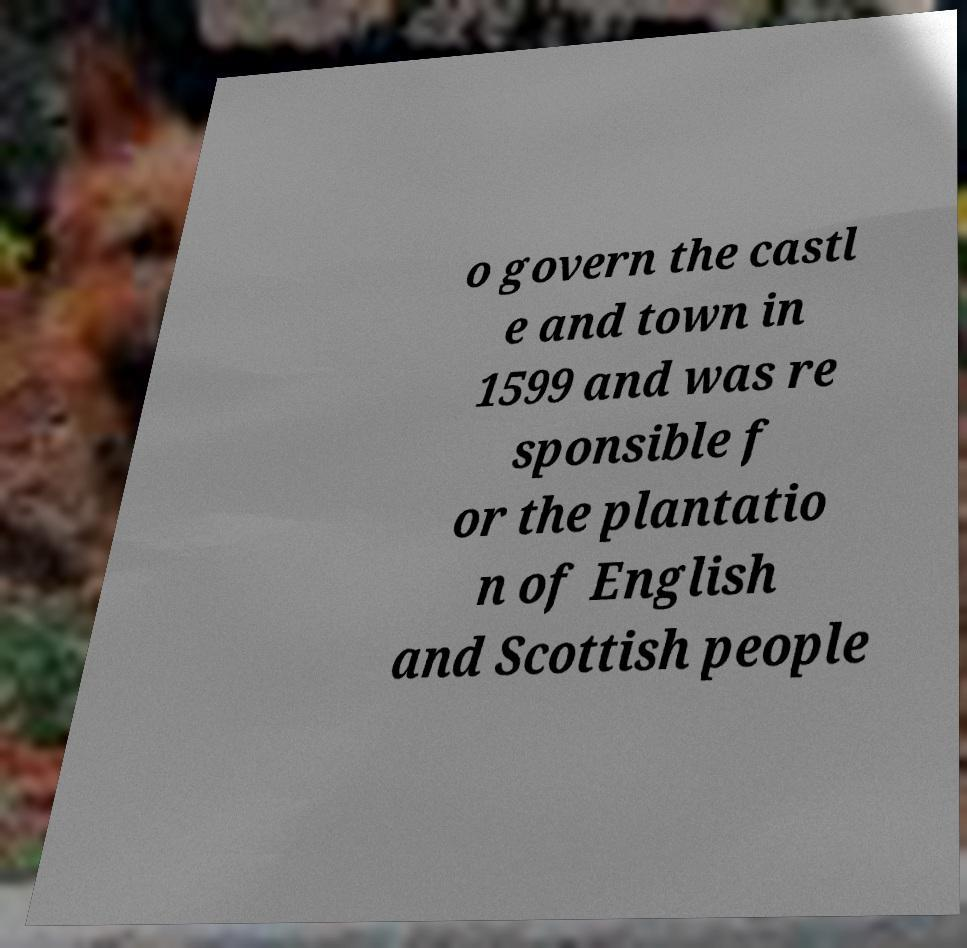I need the written content from this picture converted into text. Can you do that? o govern the castl e and town in 1599 and was re sponsible f or the plantatio n of English and Scottish people 